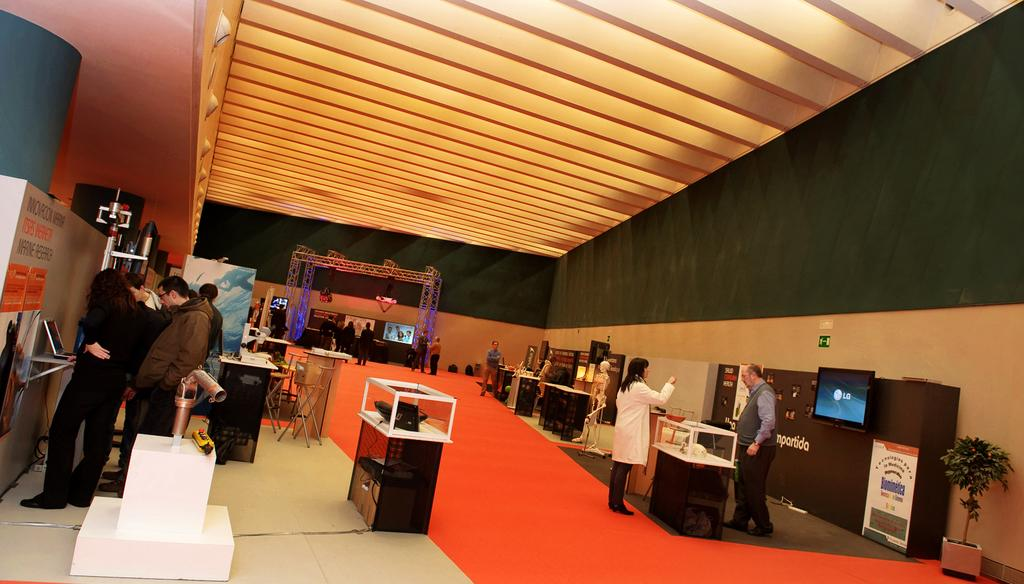What can be seen in the image in terms of people? There are people standing in the image. What electronic devices are present in the image? There is a laptop and a television in the image. Are there any plants visible in the image? Yes, there is a plant in the image. What type of board is present in the image? There is a board in the image, but the specific type is not mentioned. What is the manager's role in the organization depicted in the image? There is no mention of a manager or an organization in the image. The image only shows people, a laptop, a television, a plant, and a board. 